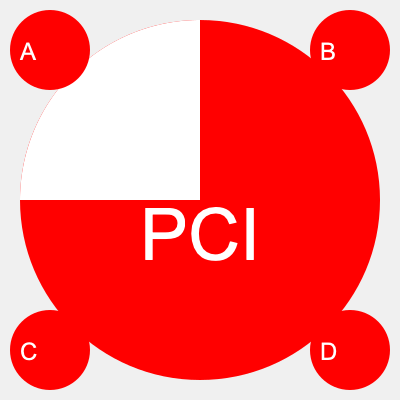The image shows the logo of the Italian Communist Party (Partito Comunista Italiano, PCI) in the center. Which of the smaller circles (A, B, C, or D) represents the correct rotation of the PCI logo by 90 degrees clockwise? To determine the correct rotation of the PCI logo by 90 degrees clockwise, we need to follow these steps:

1. Observe the original logo in the center:
   - It consists of a red circle with a white semicircle on the left side.
   - The letters "PCI" are written in white on the red portion.

2. Visualize a 90-degree clockwise rotation:
   - The white semicircle would move from the left side to the top.
   - The "PCI" text would rotate accordingly, appearing on the bottom right quadrant.

3. Examine the options:
   A: Shows the logo rotated 270° clockwise (or 90° counterclockwise)
   B: Shows the original logo without rotation
   C: Shows the logo rotated 90° clockwise
   D: Shows the logo rotated 180°

4. Compare the rotated mental image with the given options:
   Option C matches our visualization of a 90° clockwise rotation.

Therefore, the correct answer is C, as it shows the PCI logo rotated 90 degrees clockwise from its original position.
Answer: C 